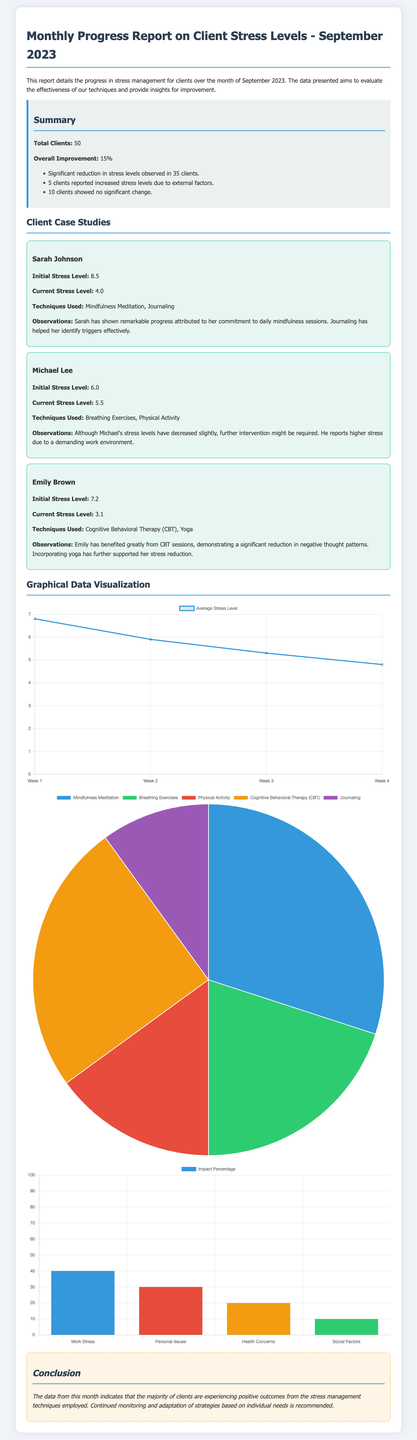What is the title of the report? The title is prominently displayed at the top of the document, indicating the subject and date of the report.
Answer: Monthly Progress Report on Client Stress Levels - September 2023 How many clients showed a significant reduction in stress levels? The summary section details that 35 clients experienced a notable decline in stress levels.
Answer: 35 clients What is the overall improvement percentage in stress levels? The summary section explicitly states the percentage improvement observed among clients.
Answer: 15% What was Sarah Johnson's initial stress level? The case study section for Sarah Johnson provides her initial stress level for reference.
Answer: 8.5 Which technique was used by the majority of clients? The techniques effectiveness chart reflects the popularity of each technique, revealing which were most utilized.
Answer: Mindfulness Meditation What external factor had the highest impact percentage? The external factors impact chart highlights the various factors and their respective impacts, identifying the most significant.
Answer: Work Stress What is the current stress level of Emily Brown? The case study for Emily Brown specifies her current stress level, which shows her progress over the month.
Answer: 3.1 What type of chart illustrates stress levels over time? The specific type of chart for tracking stress levels over the month is described in the document.
Answer: Line chart How many clients reported increased stress levels due to external factors? The summary mentions a specific number of clients who experienced increased stress due to external issues.
Answer: 5 clients 